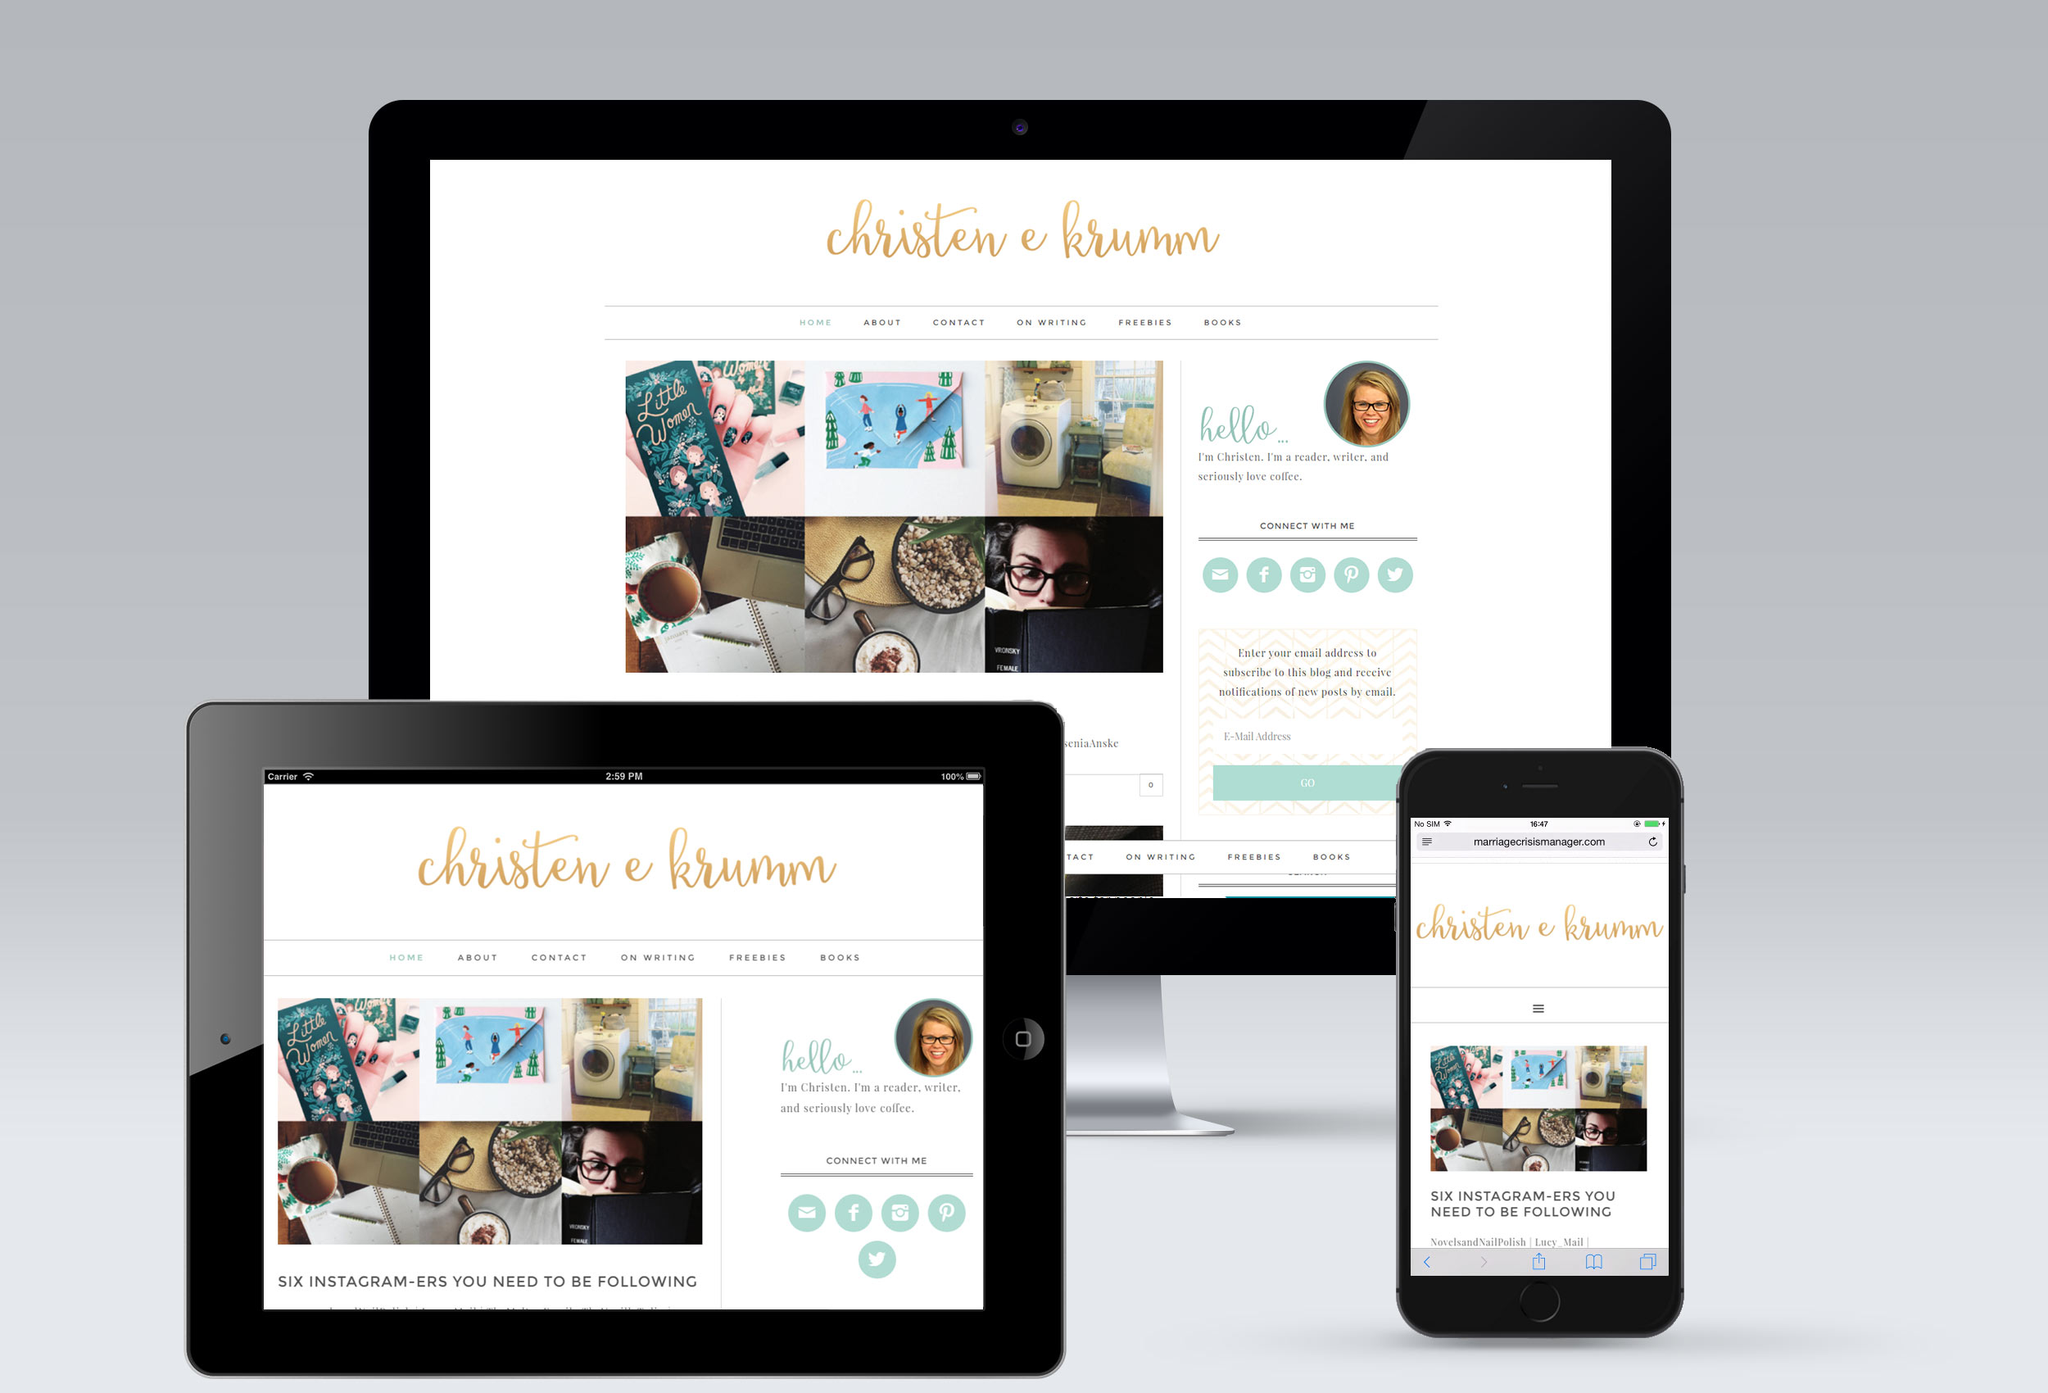Considering the nature of the website content and the items displayed in the images on the website, what could be the target audience for this website and why might the choice of visual elements appeal to that audience? The target audience for this website likely includes young adults and mid-career professionals interested in lifestyle, creativity, and personal development. The visual elements such as a cozy desk setup, coffee cup, and decorative items showcases a warm, inviting atmosphere that speaks to those who appreciate aesthetic design and thoughtful content. This setting resonates with individuals pursuing a blend of work-life integration, where calm and orderly environments enhance productivity and creativity. The website's layout and imagery suggest it caters to those who enjoy learning about social media trends, writing, and personal growth, all the while encouraging them to engage with the content in a visually pleasing and comfortable virtual space. 